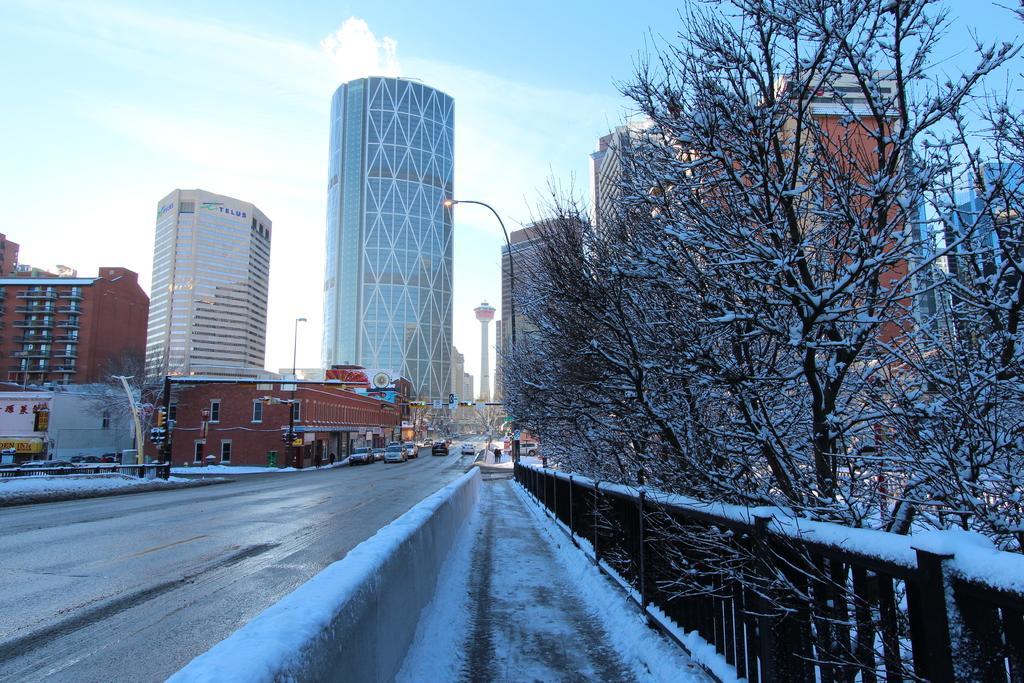Describe this image in one or two sentences. In the foreground I can see a fence, trees, light poles, buildings and fleets of cars on the road. In the background I can see the blue sky. This image is taken on the road. 